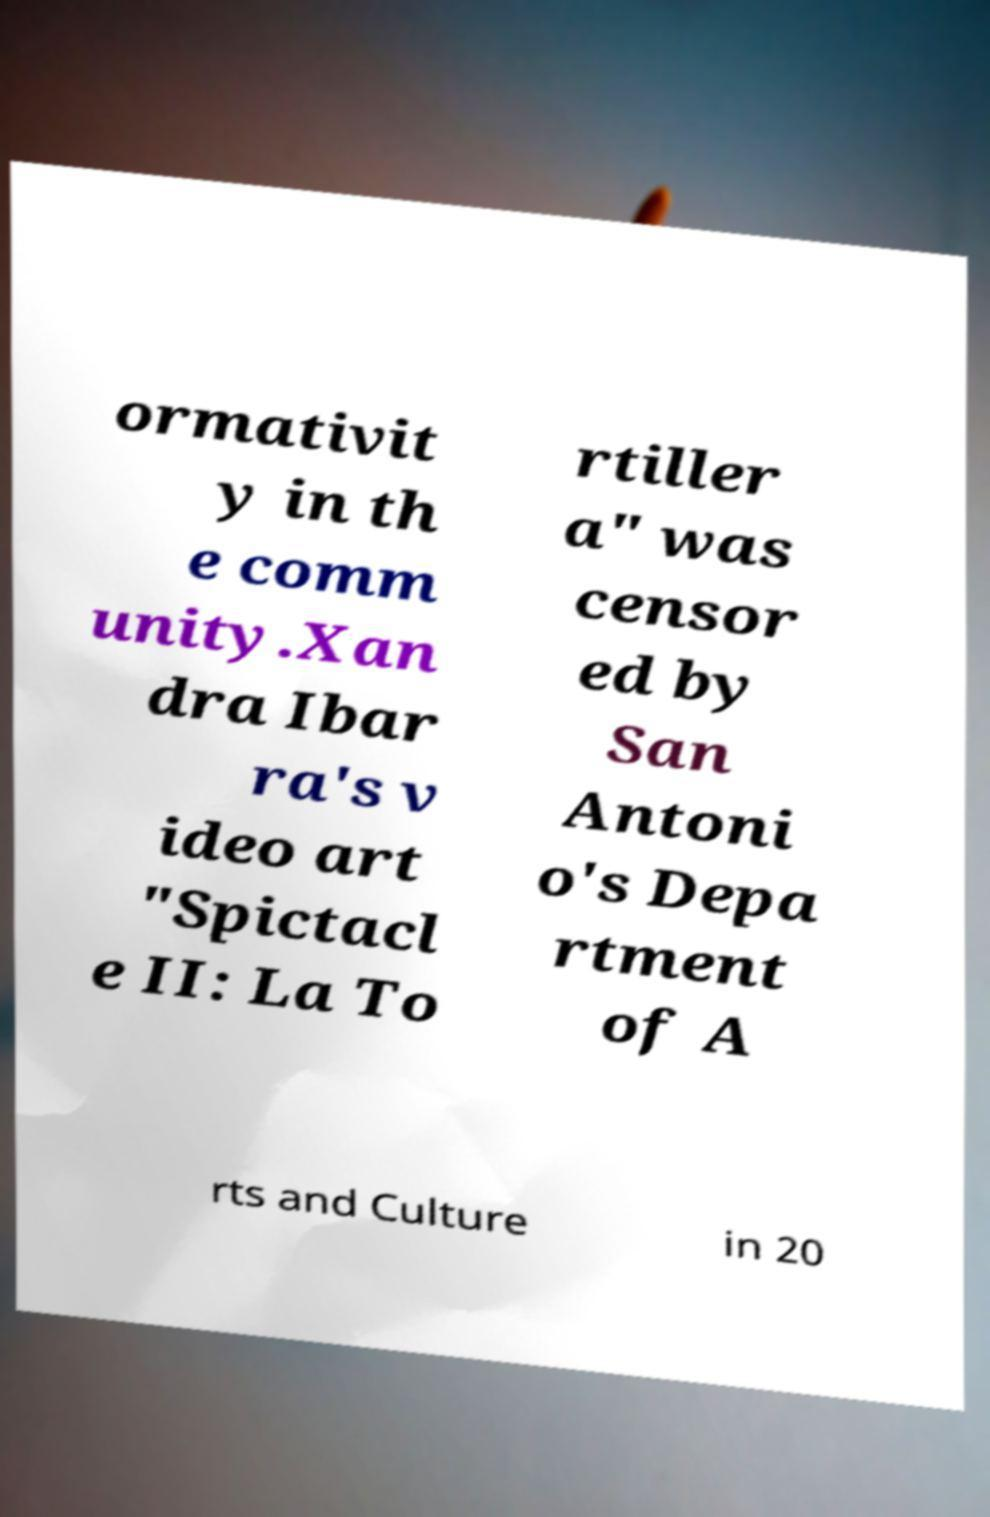What messages or text are displayed in this image? I need them in a readable, typed format. ormativit y in th e comm unity.Xan dra Ibar ra's v ideo art "Spictacl e II: La To rtiller a" was censor ed by San Antoni o's Depa rtment of A rts and Culture in 20 